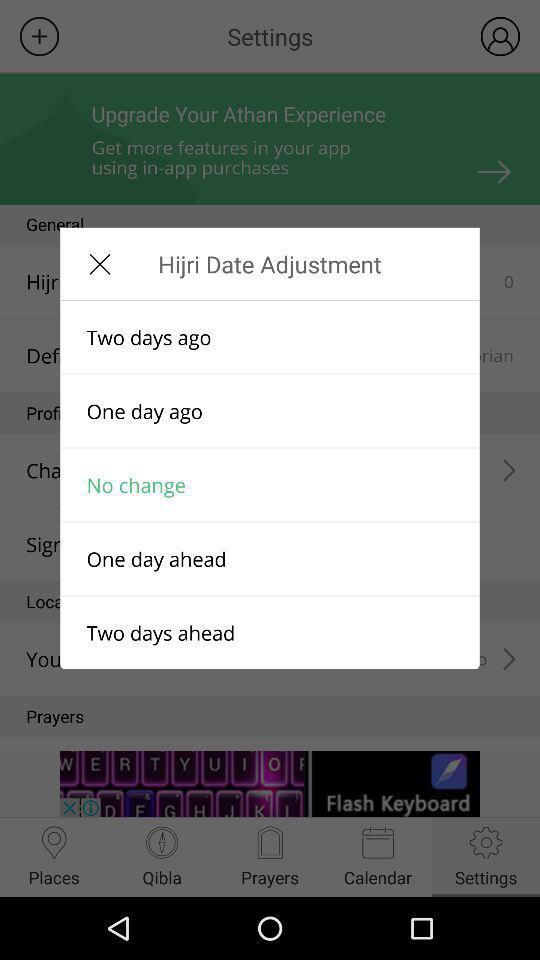What is highlighted in "Hijri Date Adjustment"? In "Hijri Date Adjustment", "No change" is highlighted. 